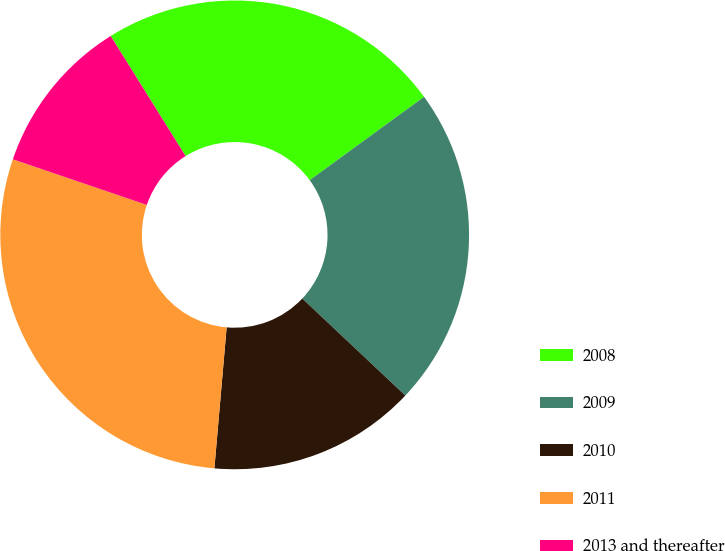<chart> <loc_0><loc_0><loc_500><loc_500><pie_chart><fcel>2008<fcel>2009<fcel>2010<fcel>2011<fcel>2013 and thereafter<nl><fcel>23.85%<fcel>22.05%<fcel>14.36%<fcel>28.85%<fcel>10.9%<nl></chart> 